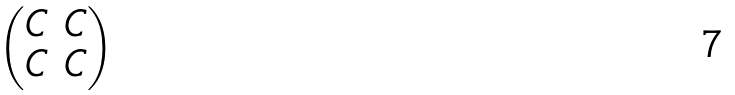Convert formula to latex. <formula><loc_0><loc_0><loc_500><loc_500>\begin{pmatrix} C & C \\ C & C \end{pmatrix}</formula> 